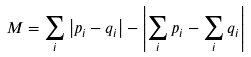<formula> <loc_0><loc_0><loc_500><loc_500>M = \sum _ { i } \left | p _ { i } - q _ { i } \right | - \left | \sum _ { i } p _ { i } - \sum _ { i } q _ { i } \right |</formula> 